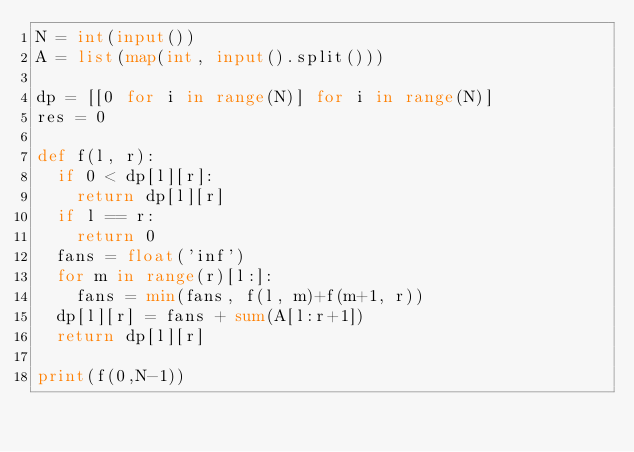<code> <loc_0><loc_0><loc_500><loc_500><_Python_>N = int(input())
A = list(map(int, input().split()))

dp = [[0 for i in range(N)] for i in range(N)]
res = 0

def f(l, r):
  if 0 < dp[l][r]:
    return dp[l][r]
  if l == r:
    return 0
  fans = float('inf')
  for m in range(r)[l:]:
    fans = min(fans, f(l, m)+f(m+1, r))
  dp[l][r] = fans + sum(A[l:r+1])
  return dp[l][r]
  
print(f(0,N-1))
</code> 